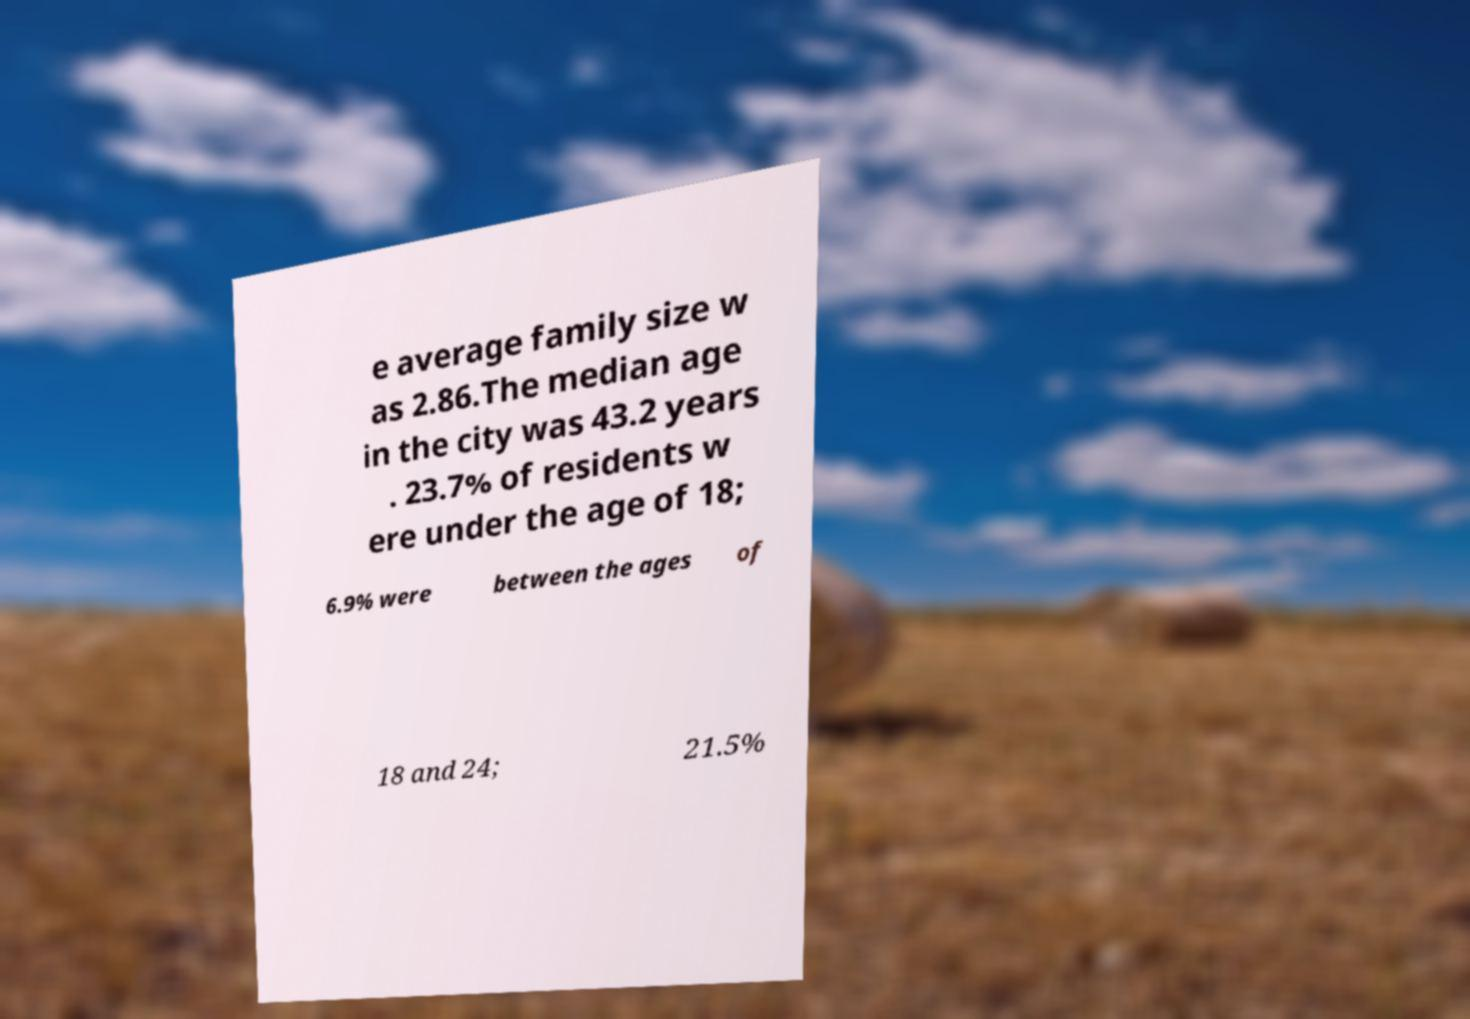Please identify and transcribe the text found in this image. e average family size w as 2.86.The median age in the city was 43.2 years . 23.7% of residents w ere under the age of 18; 6.9% were between the ages of 18 and 24; 21.5% 